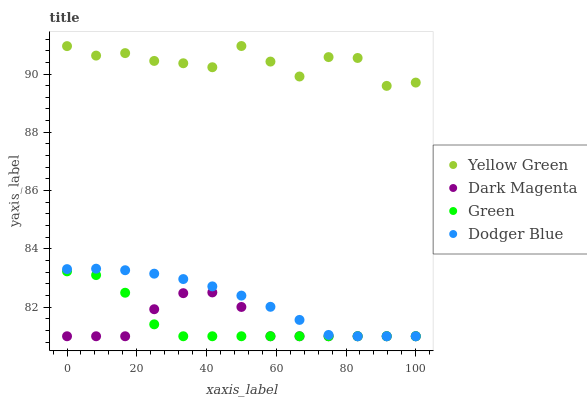Does Dark Magenta have the minimum area under the curve?
Answer yes or no. Yes. Does Yellow Green have the maximum area under the curve?
Answer yes or no. Yes. Does Green have the minimum area under the curve?
Answer yes or no. No. Does Green have the maximum area under the curve?
Answer yes or no. No. Is Dodger Blue the smoothest?
Answer yes or no. Yes. Is Yellow Green the roughest?
Answer yes or no. Yes. Is Green the smoothest?
Answer yes or no. No. Is Green the roughest?
Answer yes or no. No. Does Dodger Blue have the lowest value?
Answer yes or no. Yes. Does Yellow Green have the lowest value?
Answer yes or no. No. Does Yellow Green have the highest value?
Answer yes or no. Yes. Does Green have the highest value?
Answer yes or no. No. Is Dodger Blue less than Yellow Green?
Answer yes or no. Yes. Is Yellow Green greater than Dark Magenta?
Answer yes or no. Yes. Does Green intersect Dark Magenta?
Answer yes or no. Yes. Is Green less than Dark Magenta?
Answer yes or no. No. Is Green greater than Dark Magenta?
Answer yes or no. No. Does Dodger Blue intersect Yellow Green?
Answer yes or no. No. 